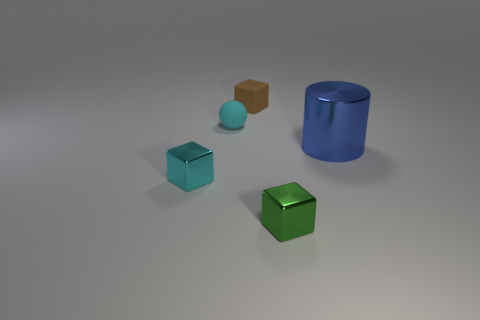Are there more shiny cylinders to the right of the green thing than large blue cylinders that are on the left side of the small cyan matte ball? While it appears there's only one shiny cylinder to the right of the green cube, and no large blue cylinders to the left of the small cyan matte ball, it's important to note that the image shows limited perspective. Based on what we can see, the answer is yes, since there are no blue cylinders on the left to compare with. 